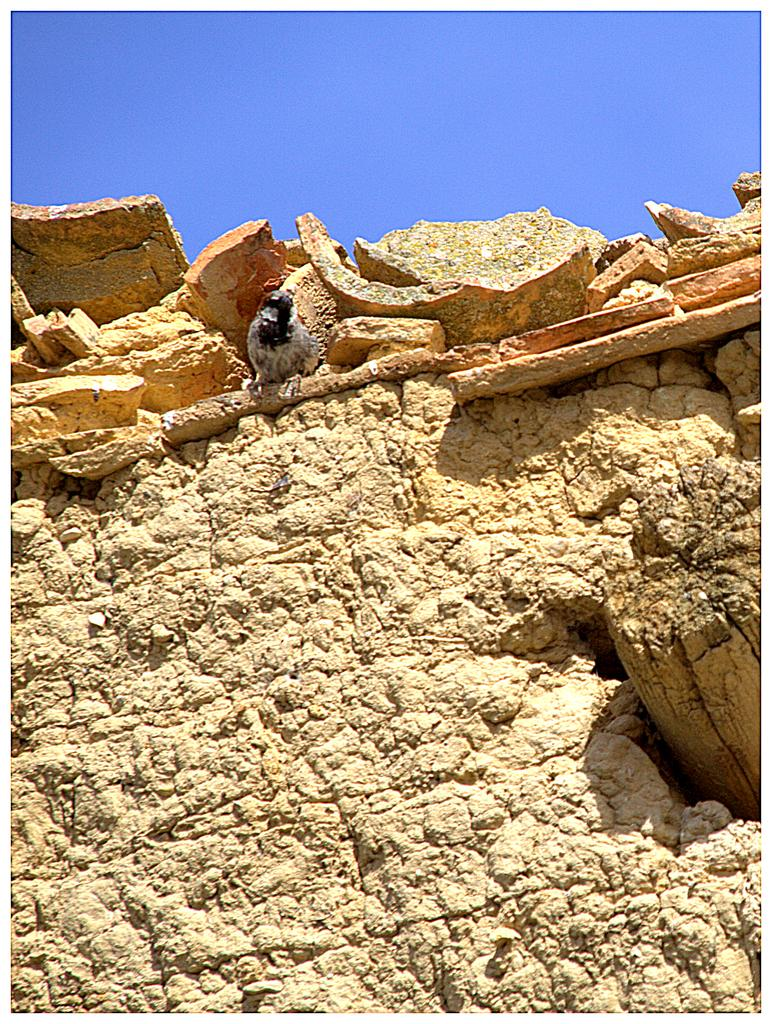What is on the wall in the image? There is a bird on the wall in the image. What can be seen in the background of the image? The sky is visible in the image. What type of natural elements are present in the image? There are rocks and wood in the image. What type of memory is stored in the bird's brain in the image? There is no indication in the image that the bird has any specific memory, and therefore it cannot be determined from the image. 